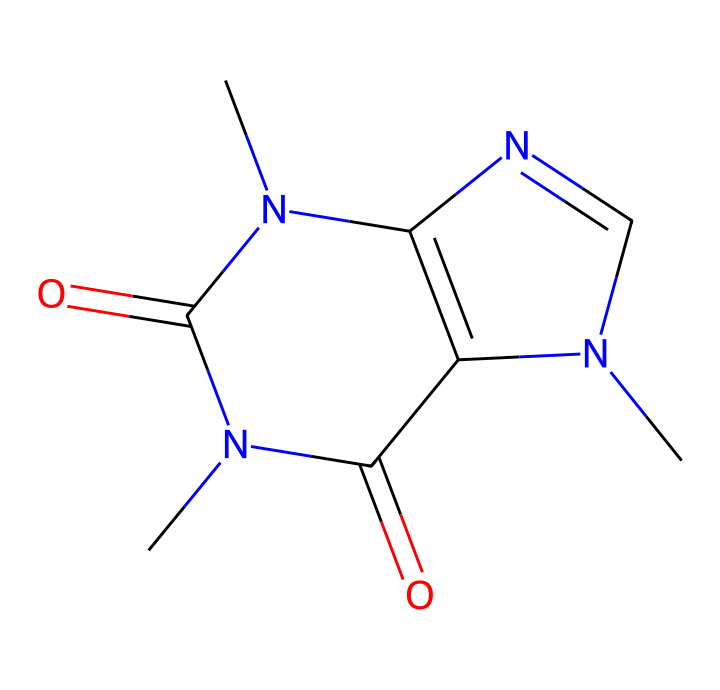What is the molecular formula of caffeine? To determine the molecular formula, we need to count the atoms of each element in the SMILES representation. From the SMILES, we find carbon (C), hydrogen (H), nitrogen (N), and oxygen (O). The count reveals C8, H10, N4, and O2. Combining these gives the molecular formula C8H10N4O2.
Answer: C8H10N4O2 How many rings are present in the structure of caffeine? By examining the SMILES representation, we observe that the structure includes two nitrogen-containing rings. Each ring is characterized by the numbering of the atoms that connect back to the starting point, which indicates a cyclic structure. Hence, there are two rings in caffeine's structure.
Answer: 2 How many nitrogen atoms are in caffeine? In the SMILES representation, nitrogen atoms are represented as 'N'. By counting each occurrence of 'N', we find there are four nitrogen atoms present in the caffeine structure.
Answer: 4 What functional groups are present in caffeine? Analyzing the structure of caffeine reveals the presence of amine groups (due to nitrogen atoms) and carbonyl groups (due to the presence of C=O). The combination of these functional groups indicates caffeine is an alkaloid.
Answer: alkaloid Which part of caffeine contributes to its stimulant properties? The presence of nitrogen atoms, particularly in the context of rings and aromatic systems, play a crucial role in the biological activity of caffeine as a stimulant, as they interact with neurotransmitter receptors in the brain.
Answer: nitrogen atoms 